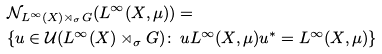<formula> <loc_0><loc_0><loc_500><loc_500>& \mathcal { N } _ { L ^ { \infty } ( X ) \rtimes _ { \sigma } G } ( L ^ { \infty } ( X , \mu ) ) = \\ & \{ u \in \mathcal { U } ( L ^ { \infty } ( X ) \rtimes _ { \sigma } G ) \colon \, u L ^ { \infty } ( X , \mu ) u ^ { * } = L ^ { \infty } ( X , \mu ) \}</formula> 